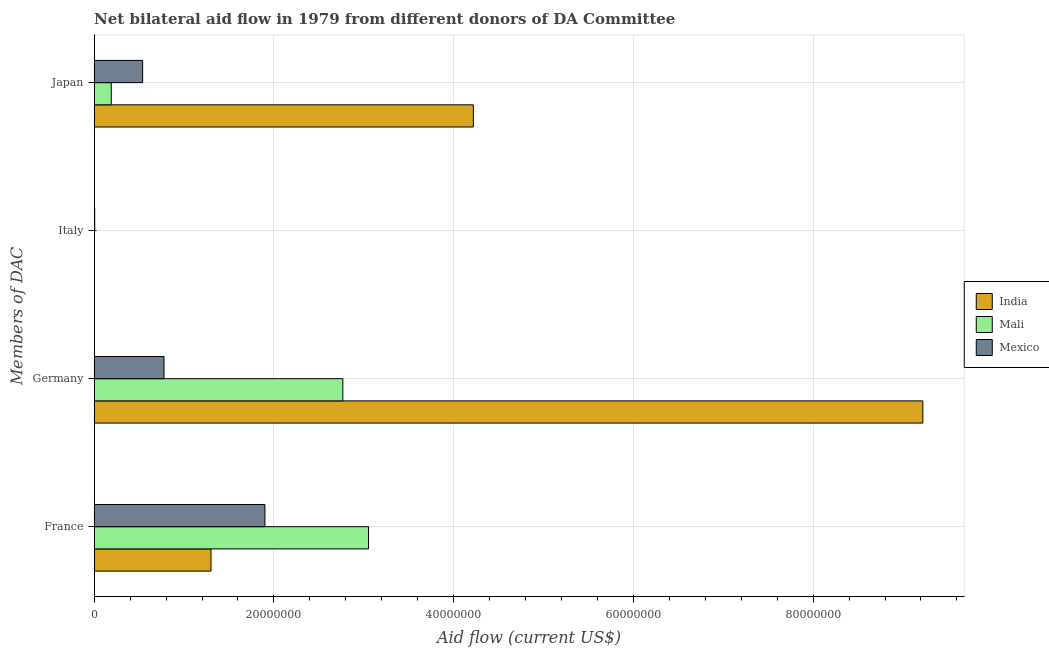Are the number of bars on each tick of the Y-axis equal?
Ensure brevity in your answer.  No. How many bars are there on the 2nd tick from the top?
Your answer should be very brief. 2. What is the amount of aid given by germany in India?
Offer a terse response. 9.22e+07. Across all countries, what is the maximum amount of aid given by france?
Make the answer very short. 3.05e+07. Across all countries, what is the minimum amount of aid given by japan?
Ensure brevity in your answer.  1.90e+06. In which country was the amount of aid given by italy maximum?
Provide a succinct answer. Mexico. What is the total amount of aid given by japan in the graph?
Your response must be concise. 4.95e+07. What is the difference between the amount of aid given by germany in India and that in Mali?
Your response must be concise. 6.45e+07. What is the difference between the amount of aid given by germany in Mexico and the amount of aid given by france in India?
Ensure brevity in your answer.  -5.23e+06. What is the average amount of aid given by italy per country?
Give a very brief answer. 3.00e+04. What is the difference between the amount of aid given by france and amount of aid given by japan in Mali?
Your answer should be compact. 2.86e+07. In how many countries, is the amount of aid given by italy greater than 12000000 US$?
Keep it short and to the point. 0. What is the ratio of the amount of aid given by germany in Mali to that in India?
Your answer should be compact. 0.3. Is the amount of aid given by germany in Mexico less than that in Mali?
Provide a succinct answer. Yes. Is the difference between the amount of aid given by japan in Mali and India greater than the difference between the amount of aid given by france in Mali and India?
Your answer should be very brief. No. What is the difference between the highest and the second highest amount of aid given by france?
Provide a short and direct response. 1.15e+07. What is the difference between the highest and the lowest amount of aid given by germany?
Your answer should be very brief. 8.44e+07. In how many countries, is the amount of aid given by japan greater than the average amount of aid given by japan taken over all countries?
Your answer should be very brief. 1. Is the sum of the amount of aid given by france in Mali and Mexico greater than the maximum amount of aid given by germany across all countries?
Your answer should be very brief. No. Is it the case that in every country, the sum of the amount of aid given by france and amount of aid given by germany is greater than the sum of amount of aid given by japan and amount of aid given by italy?
Offer a very short reply. No. Is it the case that in every country, the sum of the amount of aid given by france and amount of aid given by germany is greater than the amount of aid given by italy?
Provide a succinct answer. Yes. How many bars are there?
Make the answer very short. 11. Are all the bars in the graph horizontal?
Your answer should be very brief. Yes. How many countries are there in the graph?
Make the answer very short. 3. Are the values on the major ticks of X-axis written in scientific E-notation?
Offer a terse response. No. Does the graph contain any zero values?
Keep it short and to the point. Yes. Does the graph contain grids?
Your answer should be very brief. Yes. How are the legend labels stacked?
Keep it short and to the point. Vertical. What is the title of the graph?
Give a very brief answer. Net bilateral aid flow in 1979 from different donors of DA Committee. Does "Uganda" appear as one of the legend labels in the graph?
Give a very brief answer. No. What is the label or title of the X-axis?
Provide a succinct answer. Aid flow (current US$). What is the label or title of the Y-axis?
Your answer should be compact. Members of DAC. What is the Aid flow (current US$) in India in France?
Your answer should be very brief. 1.30e+07. What is the Aid flow (current US$) in Mali in France?
Give a very brief answer. 3.05e+07. What is the Aid flow (current US$) in Mexico in France?
Provide a short and direct response. 1.90e+07. What is the Aid flow (current US$) of India in Germany?
Make the answer very short. 9.22e+07. What is the Aid flow (current US$) in Mali in Germany?
Keep it short and to the point. 2.77e+07. What is the Aid flow (current US$) in Mexico in Germany?
Provide a succinct answer. 7.77e+06. What is the Aid flow (current US$) in India in Italy?
Offer a very short reply. 0. What is the Aid flow (current US$) of Mali in Italy?
Provide a succinct answer. 3.00e+04. What is the Aid flow (current US$) of India in Japan?
Offer a very short reply. 4.22e+07. What is the Aid flow (current US$) in Mali in Japan?
Offer a very short reply. 1.90e+06. What is the Aid flow (current US$) of Mexico in Japan?
Offer a terse response. 5.39e+06. Across all Members of DAC, what is the maximum Aid flow (current US$) of India?
Your answer should be very brief. 9.22e+07. Across all Members of DAC, what is the maximum Aid flow (current US$) in Mali?
Ensure brevity in your answer.  3.05e+07. Across all Members of DAC, what is the maximum Aid flow (current US$) of Mexico?
Offer a terse response. 1.90e+07. Across all Members of DAC, what is the minimum Aid flow (current US$) of India?
Provide a short and direct response. 0. Across all Members of DAC, what is the minimum Aid flow (current US$) in Mali?
Your answer should be very brief. 3.00e+04. Across all Members of DAC, what is the minimum Aid flow (current US$) of Mexico?
Provide a short and direct response. 6.00e+04. What is the total Aid flow (current US$) of India in the graph?
Provide a succinct answer. 1.47e+08. What is the total Aid flow (current US$) of Mali in the graph?
Ensure brevity in your answer.  6.01e+07. What is the total Aid flow (current US$) in Mexico in the graph?
Provide a short and direct response. 3.22e+07. What is the difference between the Aid flow (current US$) of India in France and that in Germany?
Provide a succinct answer. -7.92e+07. What is the difference between the Aid flow (current US$) of Mali in France and that in Germany?
Make the answer very short. 2.86e+06. What is the difference between the Aid flow (current US$) in Mexico in France and that in Germany?
Offer a very short reply. 1.12e+07. What is the difference between the Aid flow (current US$) in Mali in France and that in Italy?
Your answer should be compact. 3.05e+07. What is the difference between the Aid flow (current US$) in Mexico in France and that in Italy?
Your response must be concise. 1.89e+07. What is the difference between the Aid flow (current US$) in India in France and that in Japan?
Your answer should be compact. -2.92e+07. What is the difference between the Aid flow (current US$) of Mali in France and that in Japan?
Keep it short and to the point. 2.86e+07. What is the difference between the Aid flow (current US$) in Mexico in France and that in Japan?
Ensure brevity in your answer.  1.36e+07. What is the difference between the Aid flow (current US$) in Mali in Germany and that in Italy?
Give a very brief answer. 2.76e+07. What is the difference between the Aid flow (current US$) in Mexico in Germany and that in Italy?
Make the answer very short. 7.71e+06. What is the difference between the Aid flow (current US$) of India in Germany and that in Japan?
Your response must be concise. 5.00e+07. What is the difference between the Aid flow (current US$) in Mali in Germany and that in Japan?
Ensure brevity in your answer.  2.58e+07. What is the difference between the Aid flow (current US$) of Mexico in Germany and that in Japan?
Ensure brevity in your answer.  2.38e+06. What is the difference between the Aid flow (current US$) in Mali in Italy and that in Japan?
Offer a very short reply. -1.87e+06. What is the difference between the Aid flow (current US$) of Mexico in Italy and that in Japan?
Make the answer very short. -5.33e+06. What is the difference between the Aid flow (current US$) in India in France and the Aid flow (current US$) in Mali in Germany?
Give a very brief answer. -1.47e+07. What is the difference between the Aid flow (current US$) in India in France and the Aid flow (current US$) in Mexico in Germany?
Provide a succinct answer. 5.23e+06. What is the difference between the Aid flow (current US$) of Mali in France and the Aid flow (current US$) of Mexico in Germany?
Your answer should be compact. 2.28e+07. What is the difference between the Aid flow (current US$) in India in France and the Aid flow (current US$) in Mali in Italy?
Offer a terse response. 1.30e+07. What is the difference between the Aid flow (current US$) of India in France and the Aid flow (current US$) of Mexico in Italy?
Offer a terse response. 1.29e+07. What is the difference between the Aid flow (current US$) in Mali in France and the Aid flow (current US$) in Mexico in Italy?
Give a very brief answer. 3.05e+07. What is the difference between the Aid flow (current US$) of India in France and the Aid flow (current US$) of Mali in Japan?
Give a very brief answer. 1.11e+07. What is the difference between the Aid flow (current US$) of India in France and the Aid flow (current US$) of Mexico in Japan?
Provide a short and direct response. 7.61e+06. What is the difference between the Aid flow (current US$) in Mali in France and the Aid flow (current US$) in Mexico in Japan?
Keep it short and to the point. 2.51e+07. What is the difference between the Aid flow (current US$) in India in Germany and the Aid flow (current US$) in Mali in Italy?
Keep it short and to the point. 9.22e+07. What is the difference between the Aid flow (current US$) in India in Germany and the Aid flow (current US$) in Mexico in Italy?
Offer a terse response. 9.22e+07. What is the difference between the Aid flow (current US$) in Mali in Germany and the Aid flow (current US$) in Mexico in Italy?
Your response must be concise. 2.76e+07. What is the difference between the Aid flow (current US$) of India in Germany and the Aid flow (current US$) of Mali in Japan?
Your response must be concise. 9.03e+07. What is the difference between the Aid flow (current US$) of India in Germany and the Aid flow (current US$) of Mexico in Japan?
Provide a succinct answer. 8.68e+07. What is the difference between the Aid flow (current US$) in Mali in Germany and the Aid flow (current US$) in Mexico in Japan?
Give a very brief answer. 2.23e+07. What is the difference between the Aid flow (current US$) of Mali in Italy and the Aid flow (current US$) of Mexico in Japan?
Provide a short and direct response. -5.36e+06. What is the average Aid flow (current US$) of India per Members of DAC?
Your response must be concise. 3.68e+07. What is the average Aid flow (current US$) in Mali per Members of DAC?
Provide a succinct answer. 1.50e+07. What is the average Aid flow (current US$) of Mexico per Members of DAC?
Your answer should be compact. 8.06e+06. What is the difference between the Aid flow (current US$) in India and Aid flow (current US$) in Mali in France?
Provide a short and direct response. -1.75e+07. What is the difference between the Aid flow (current US$) in India and Aid flow (current US$) in Mexico in France?
Offer a very short reply. -6.00e+06. What is the difference between the Aid flow (current US$) of Mali and Aid flow (current US$) of Mexico in France?
Offer a very short reply. 1.15e+07. What is the difference between the Aid flow (current US$) of India and Aid flow (current US$) of Mali in Germany?
Offer a terse response. 6.45e+07. What is the difference between the Aid flow (current US$) in India and Aid flow (current US$) in Mexico in Germany?
Give a very brief answer. 8.44e+07. What is the difference between the Aid flow (current US$) of Mali and Aid flow (current US$) of Mexico in Germany?
Your response must be concise. 1.99e+07. What is the difference between the Aid flow (current US$) of India and Aid flow (current US$) of Mali in Japan?
Make the answer very short. 4.03e+07. What is the difference between the Aid flow (current US$) in India and Aid flow (current US$) in Mexico in Japan?
Your answer should be very brief. 3.68e+07. What is the difference between the Aid flow (current US$) in Mali and Aid flow (current US$) in Mexico in Japan?
Provide a succinct answer. -3.49e+06. What is the ratio of the Aid flow (current US$) in India in France to that in Germany?
Your answer should be very brief. 0.14. What is the ratio of the Aid flow (current US$) in Mali in France to that in Germany?
Your response must be concise. 1.1. What is the ratio of the Aid flow (current US$) in Mexico in France to that in Germany?
Your answer should be compact. 2.45. What is the ratio of the Aid flow (current US$) of Mali in France to that in Italy?
Give a very brief answer. 1017.67. What is the ratio of the Aid flow (current US$) in Mexico in France to that in Italy?
Offer a very short reply. 316.67. What is the ratio of the Aid flow (current US$) of India in France to that in Japan?
Your answer should be very brief. 0.31. What is the ratio of the Aid flow (current US$) in Mali in France to that in Japan?
Provide a short and direct response. 16.07. What is the ratio of the Aid flow (current US$) in Mexico in France to that in Japan?
Your answer should be very brief. 3.52. What is the ratio of the Aid flow (current US$) of Mali in Germany to that in Italy?
Offer a terse response. 922.33. What is the ratio of the Aid flow (current US$) in Mexico in Germany to that in Italy?
Provide a short and direct response. 129.5. What is the ratio of the Aid flow (current US$) of India in Germany to that in Japan?
Your answer should be compact. 2.19. What is the ratio of the Aid flow (current US$) in Mali in Germany to that in Japan?
Make the answer very short. 14.56. What is the ratio of the Aid flow (current US$) in Mexico in Germany to that in Japan?
Your answer should be compact. 1.44. What is the ratio of the Aid flow (current US$) in Mali in Italy to that in Japan?
Your answer should be compact. 0.02. What is the ratio of the Aid flow (current US$) in Mexico in Italy to that in Japan?
Keep it short and to the point. 0.01. What is the difference between the highest and the second highest Aid flow (current US$) in India?
Your answer should be compact. 5.00e+07. What is the difference between the highest and the second highest Aid flow (current US$) of Mali?
Offer a very short reply. 2.86e+06. What is the difference between the highest and the second highest Aid flow (current US$) in Mexico?
Your answer should be very brief. 1.12e+07. What is the difference between the highest and the lowest Aid flow (current US$) in India?
Your answer should be very brief. 9.22e+07. What is the difference between the highest and the lowest Aid flow (current US$) in Mali?
Provide a short and direct response. 3.05e+07. What is the difference between the highest and the lowest Aid flow (current US$) in Mexico?
Give a very brief answer. 1.89e+07. 